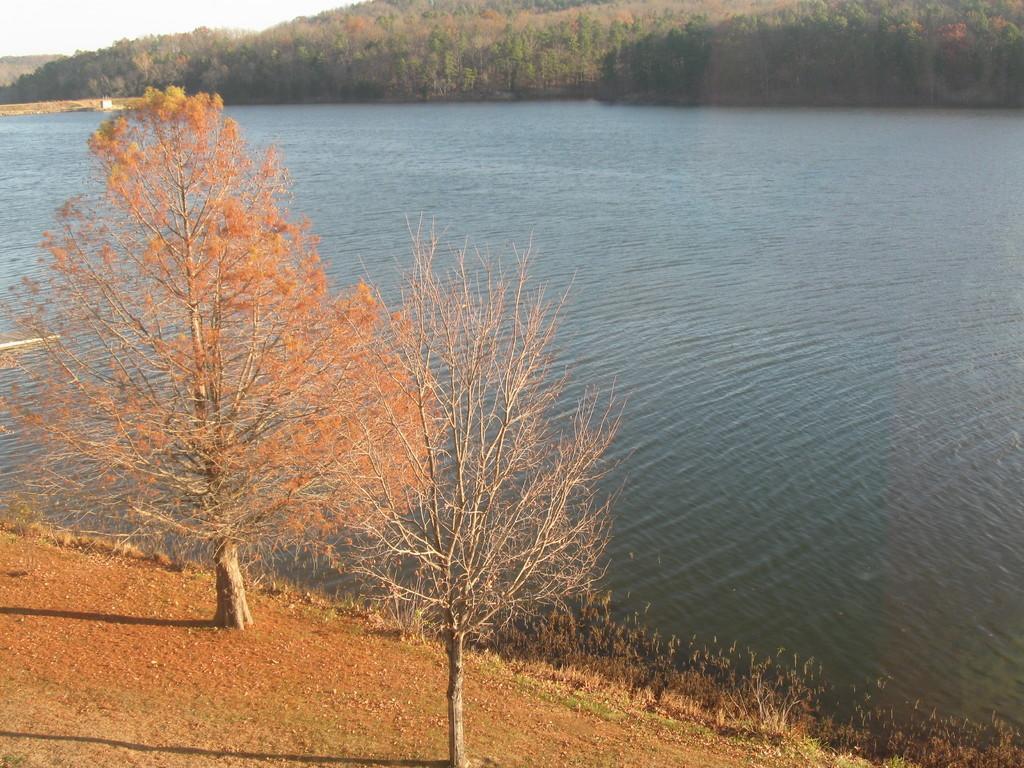Could you give a brief overview of what you see in this image? In this image we can see some trees, plants and water, in the background we can see the sky. 